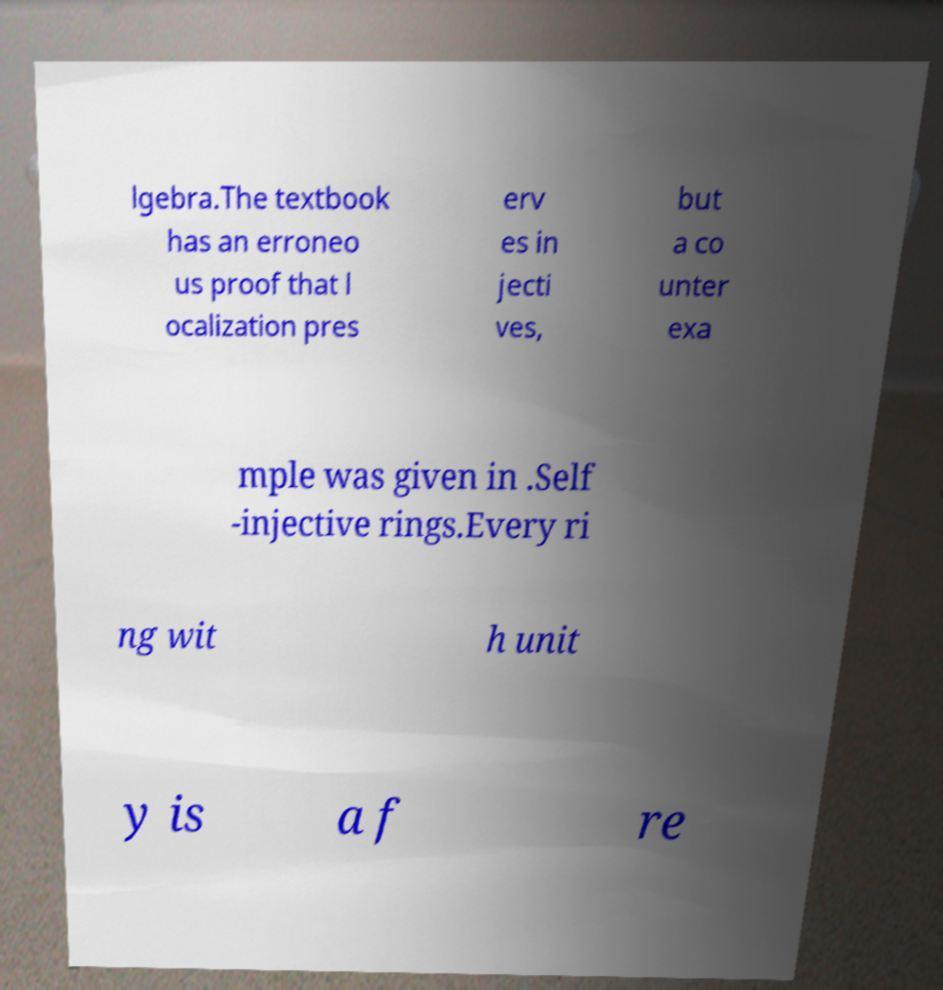There's text embedded in this image that I need extracted. Can you transcribe it verbatim? lgebra.The textbook has an erroneo us proof that l ocalization pres erv es in jecti ves, but a co unter exa mple was given in .Self -injective rings.Every ri ng wit h unit y is a f re 